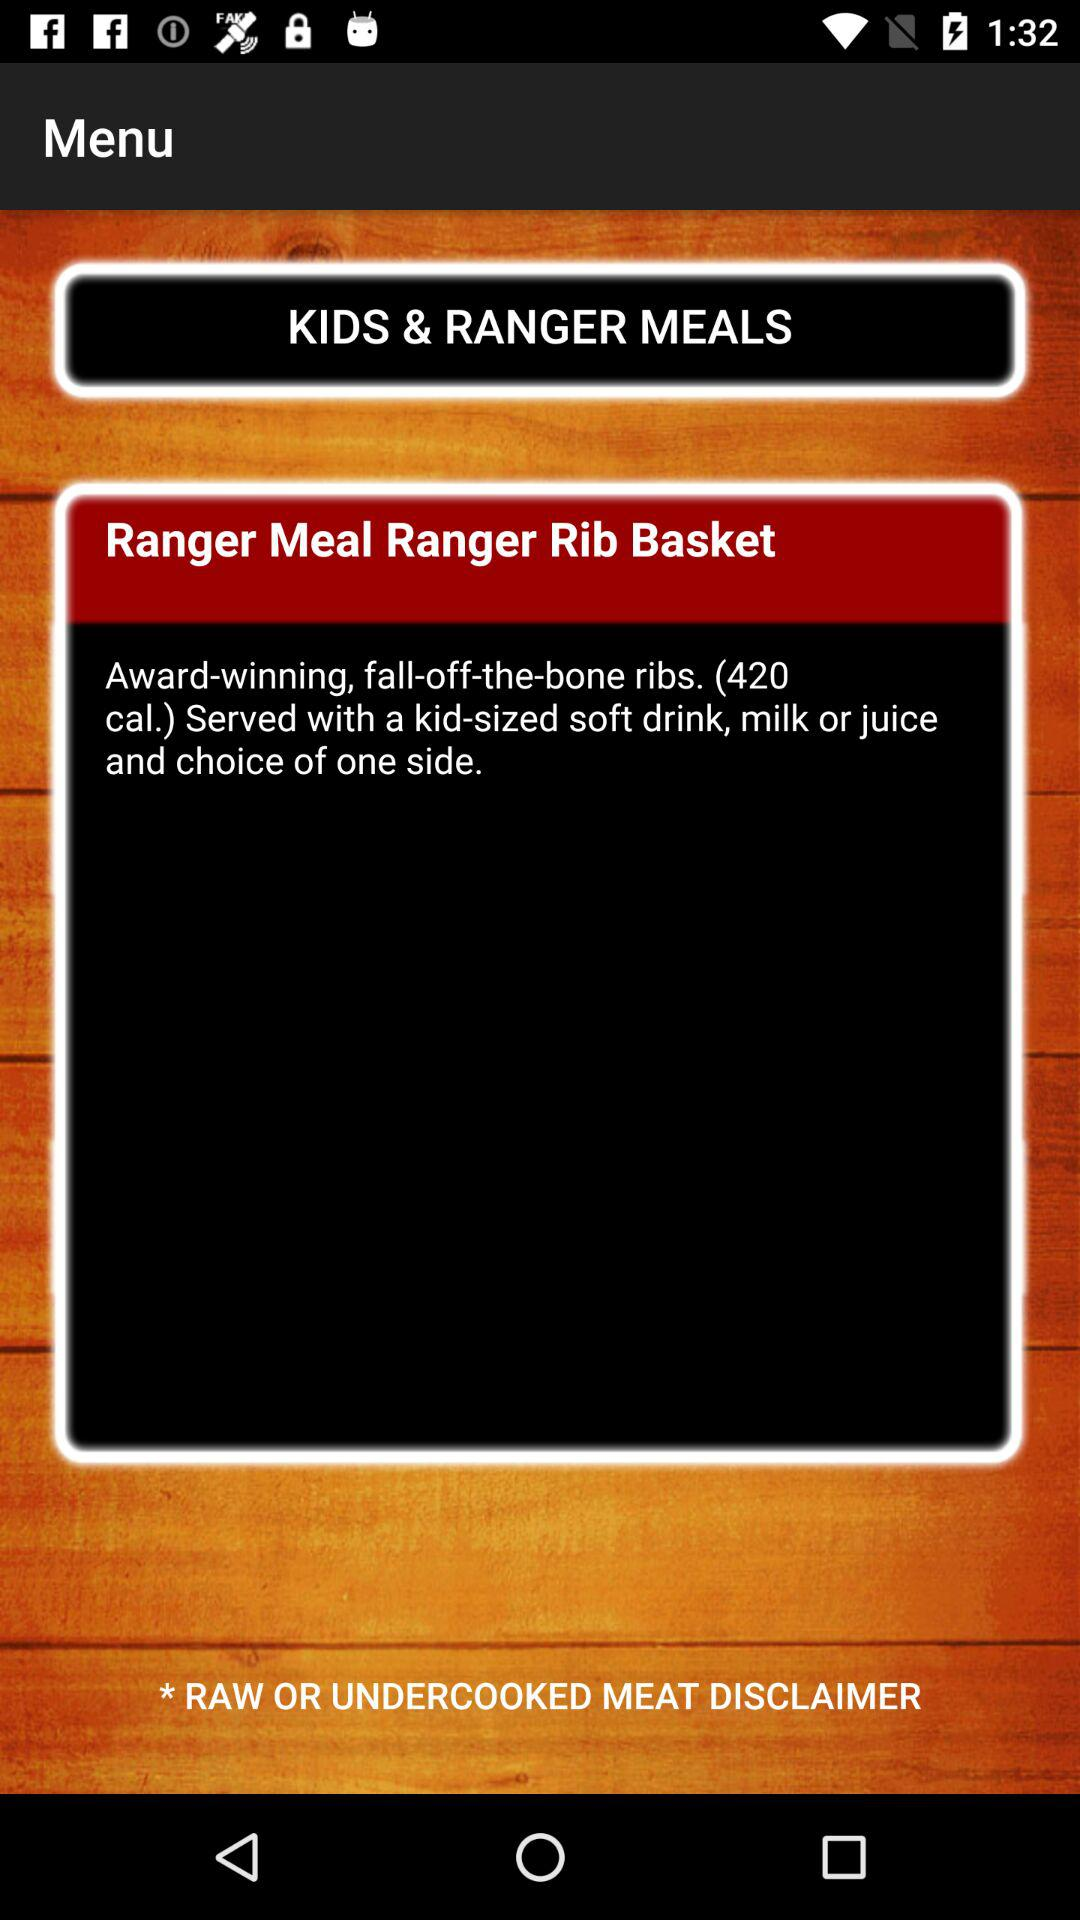How many calories are in the Ranger Rib Basket?
Answer the question using a single word or phrase. 420 